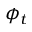<formula> <loc_0><loc_0><loc_500><loc_500>\phi _ { t }</formula> 